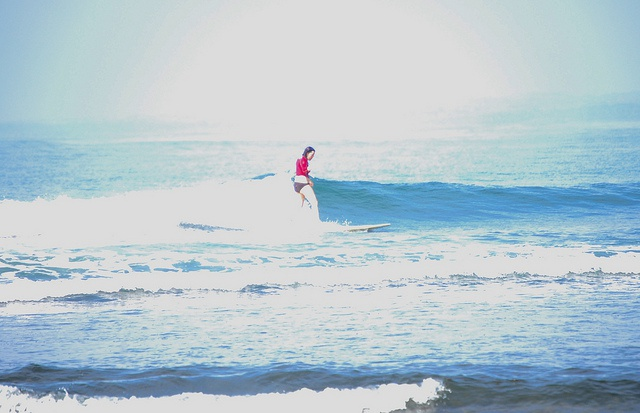Describe the objects in this image and their specific colors. I can see people in lightblue, lightgray, brown, violet, and lightpink tones and surfboard in lightblue, lightgray, darkgray, gray, and beige tones in this image. 